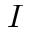<formula> <loc_0><loc_0><loc_500><loc_500>I</formula> 